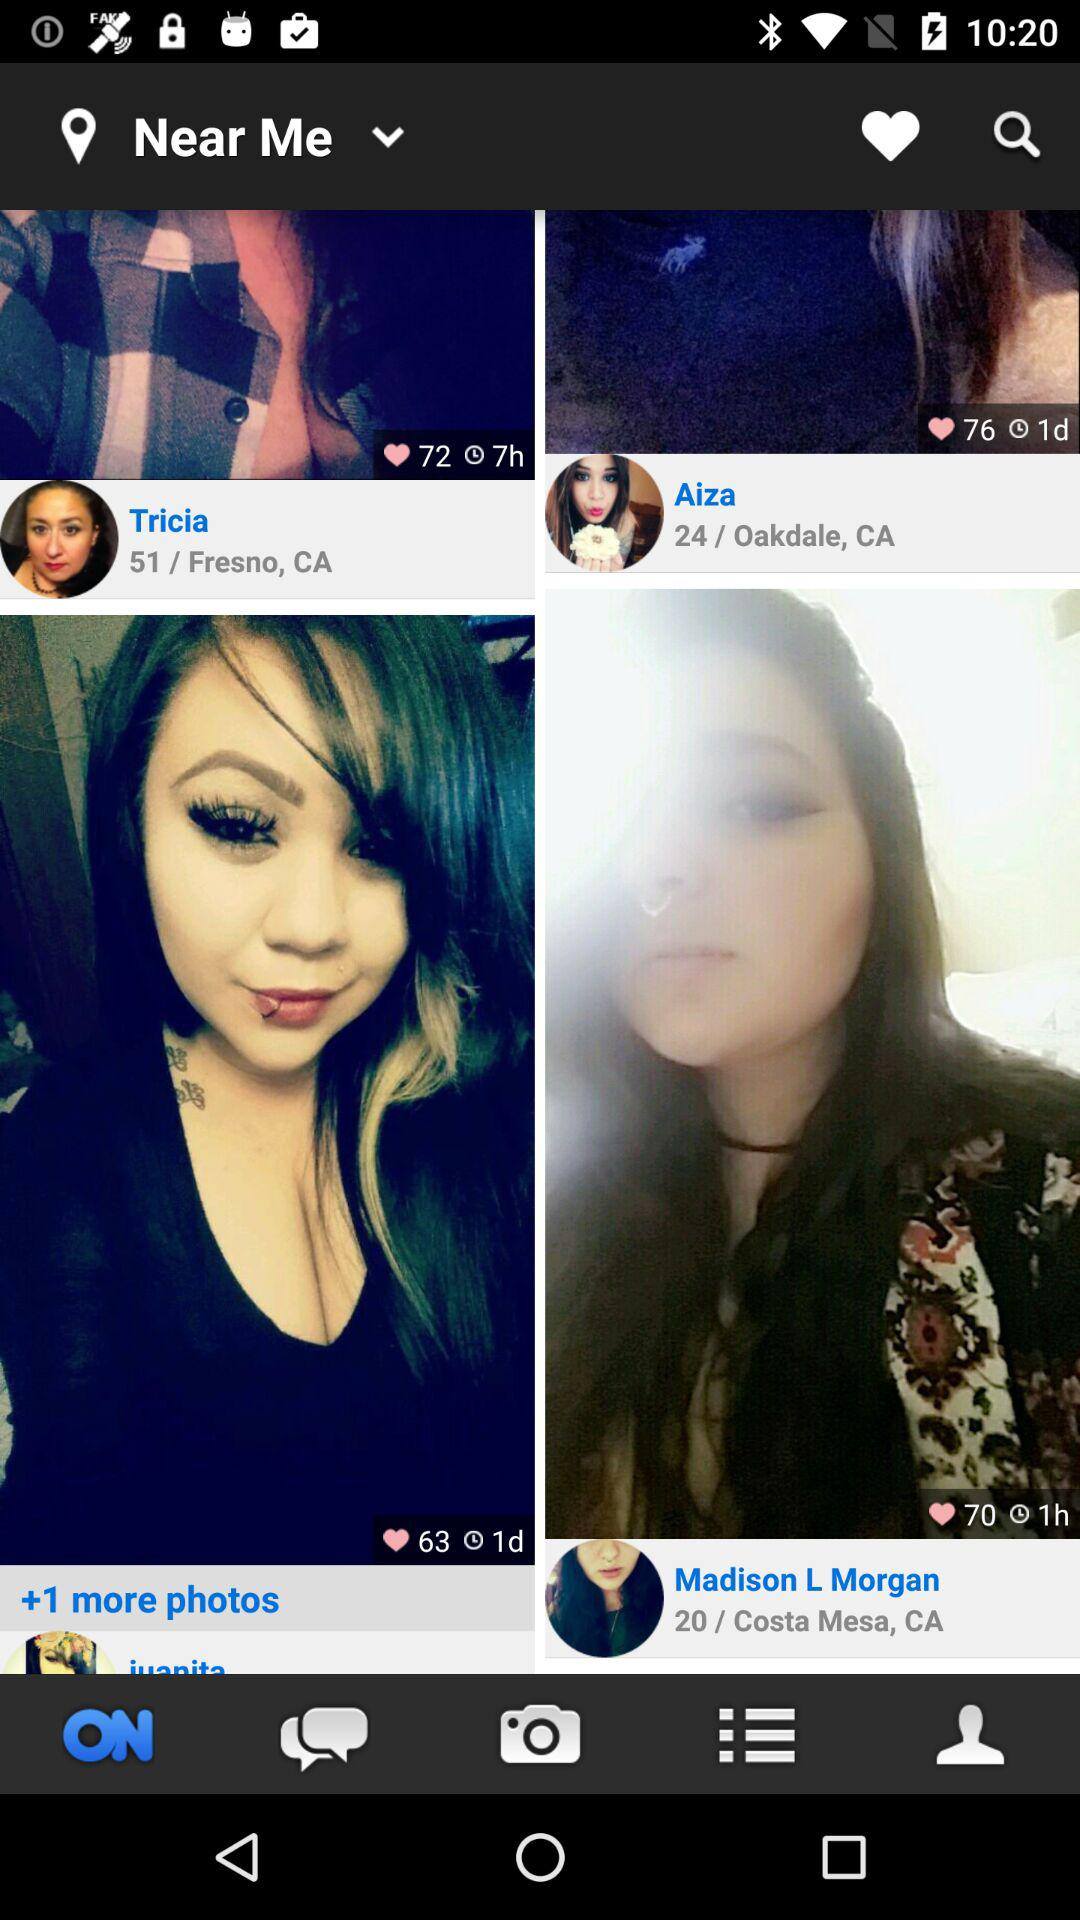What is the number of likes for Madison L. Morgan's photo? The number of likes is 70. 